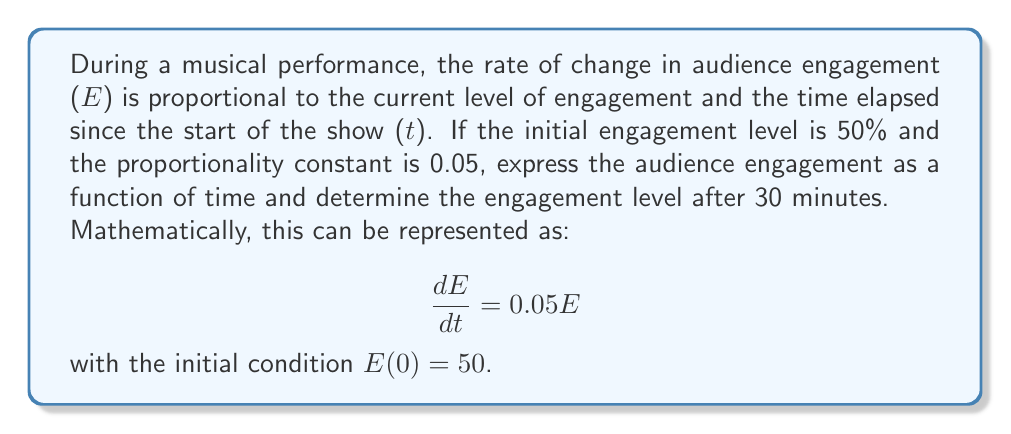Teach me how to tackle this problem. To solve this first-order differential equation, we follow these steps:

1) The general form of this differential equation is:
   $$\frac{dE}{dt} = kE$$
   where $k = 0.05$ in this case.

2) This is a separable equation. We can rewrite it as:
   $$\frac{dE}{E} = 0.05dt$$

3) Integrating both sides:
   $$\int \frac{dE}{E} = \int 0.05dt$$
   $$\ln|E| = 0.05t + C$$

4) Solving for E:
   $$E = e^{0.05t + C} = e^C \cdot e^{0.05t}$$
   Let $A = e^C$, then:
   $$E = A \cdot e^{0.05t}$$

5) Using the initial condition $E(0) = 50$:
   $$50 = A \cdot e^{0.05 \cdot 0} = A$$

6) Therefore, the solution is:
   $$E(t) = 50 \cdot e^{0.05t}$$

7) To find the engagement level after 30 minutes:
   $$E(30) = 50 \cdot e^{0.05 \cdot 30} \approx 121.55$$

This means the audience engagement level will be approximately 121.55% after 30 minutes.
Answer: The audience engagement as a function of time is $E(t) = 50 \cdot e^{0.05t}$, and the engagement level after 30 minutes is approximately 121.55%. 